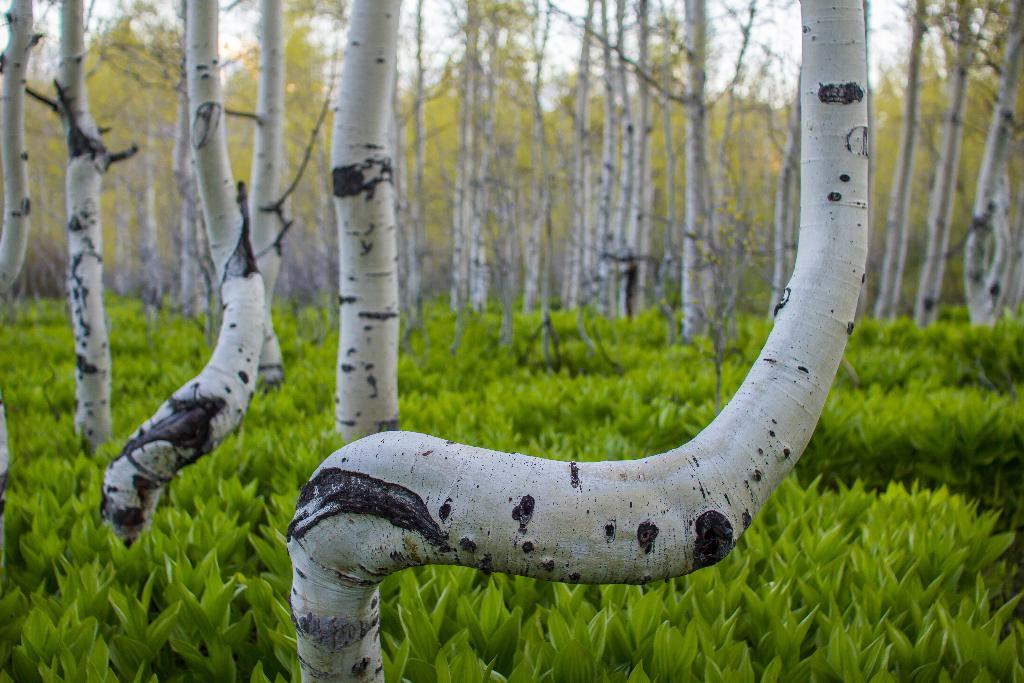What type of vegetation can be seen in the image? There are trees and plants in the image. What part of the natural environment is visible in the image? The sky is visible in the image. How many holes can be seen in the image? There are no holes present in the image. What type of room is depicted in the image? The image does not depict a room; it features trees, plants, and the sky. 